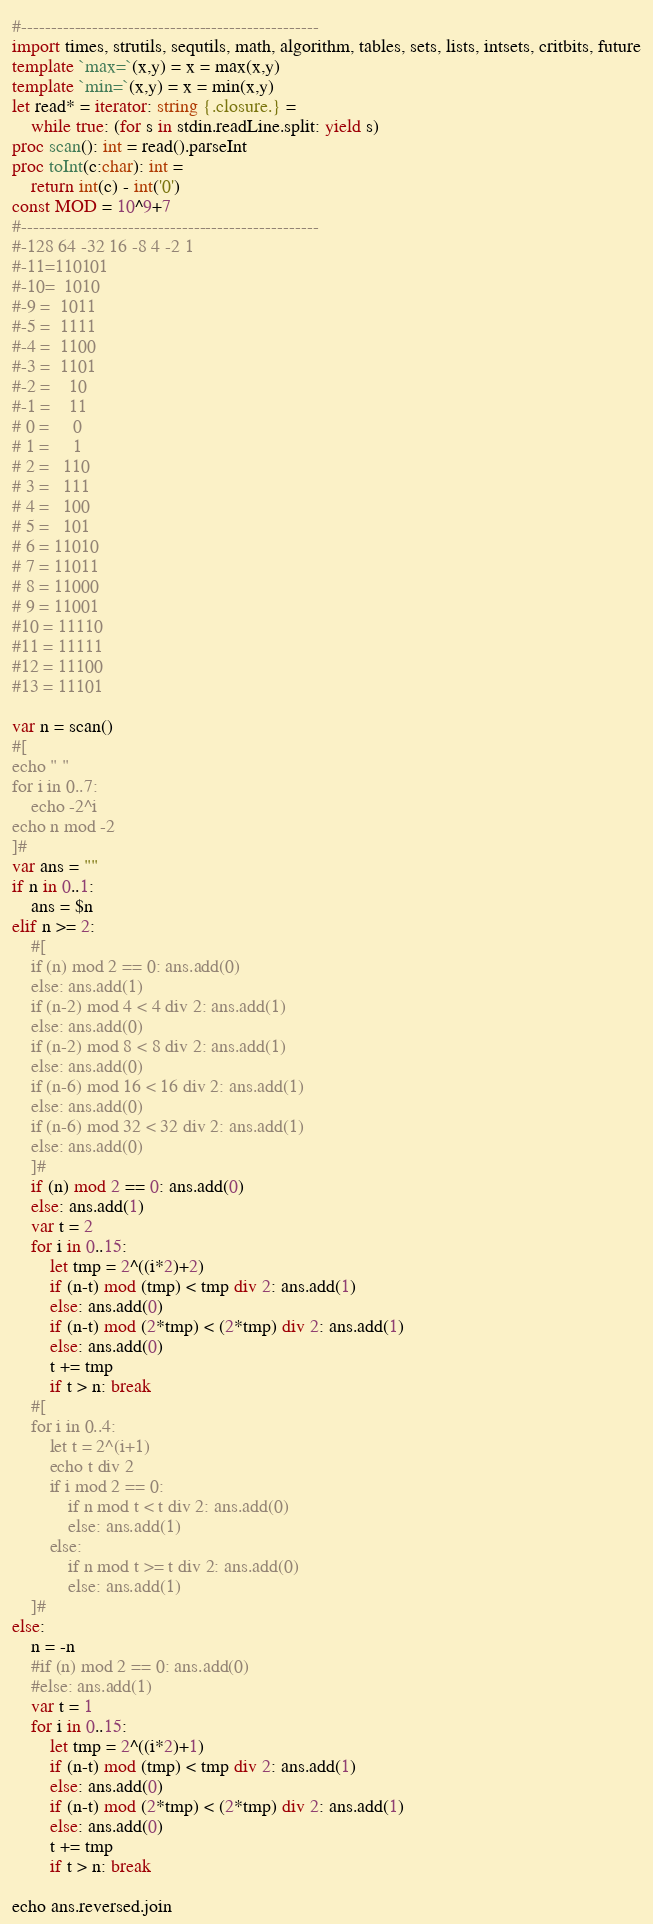<code> <loc_0><loc_0><loc_500><loc_500><_Nim_>#--------------------------------------------------
import times, strutils, sequtils, math, algorithm, tables, sets, lists, intsets, critbits, future
template `max=`(x,y) = x = max(x,y)
template `min=`(x,y) = x = min(x,y)
let read* = iterator: string {.closure.} =
    while true: (for s in stdin.readLine.split: yield s)
proc scan(): int = read().parseInt
proc toInt(c:char): int =
    return int(c) - int('0')
const MOD = 10^9+7
#--------------------------------------------------
#-128 64 -32 16 -8 4 -2 1
#-11=110101
#-10=  1010
#-9 =  1011
#-5 =  1111
#-4 =  1100
#-3 =  1101
#-2 =    10
#-1 =    11
# 0 =     0
# 1 =     1
# 2 =   110
# 3 =   111
# 4 =   100
# 5 =   101
# 6 = 11010
# 7 = 11011
# 8 = 11000
# 9 = 11001
#10 = 11110
#11 = 11111
#12 = 11100
#13 = 11101

var n = scan()
#[
echo " "
for i in 0..7:
    echo -2^i
echo n mod -2
]#
var ans = ""
if n in 0..1:
    ans = $n
elif n >= 2:
    #[
    if (n) mod 2 == 0: ans.add(0)
    else: ans.add(1)
    if (n-2) mod 4 < 4 div 2: ans.add(1)
    else: ans.add(0)
    if (n-2) mod 8 < 8 div 2: ans.add(1)
    else: ans.add(0)
    if (n-6) mod 16 < 16 div 2: ans.add(1)
    else: ans.add(0)
    if (n-6) mod 32 < 32 div 2: ans.add(1)
    else: ans.add(0)
    ]#
    if (n) mod 2 == 0: ans.add(0)
    else: ans.add(1)
    var t = 2
    for i in 0..15:
        let tmp = 2^((i*2)+2)
        if (n-t) mod (tmp) < tmp div 2: ans.add(1)
        else: ans.add(0)
        if (n-t) mod (2*tmp) < (2*tmp) div 2: ans.add(1)
        else: ans.add(0)
        t += tmp
        if t > n: break
    #[
    for i in 0..4:
        let t = 2^(i+1)
        echo t div 2
        if i mod 2 == 0:
            if n mod t < t div 2: ans.add(0)
            else: ans.add(1)
        else:
            if n mod t >= t div 2: ans.add(0)
            else: ans.add(1)
    ]#
else:
    n = -n
    #if (n) mod 2 == 0: ans.add(0)
    #else: ans.add(1)
    var t = 1
    for i in 0..15:
        let tmp = 2^((i*2)+1)
        if (n-t) mod (tmp) < tmp div 2: ans.add(1)
        else: ans.add(0)
        if (n-t) mod (2*tmp) < (2*tmp) div 2: ans.add(1)
        else: ans.add(0)
        t += tmp
        if t > n: break

echo ans.reversed.join</code> 